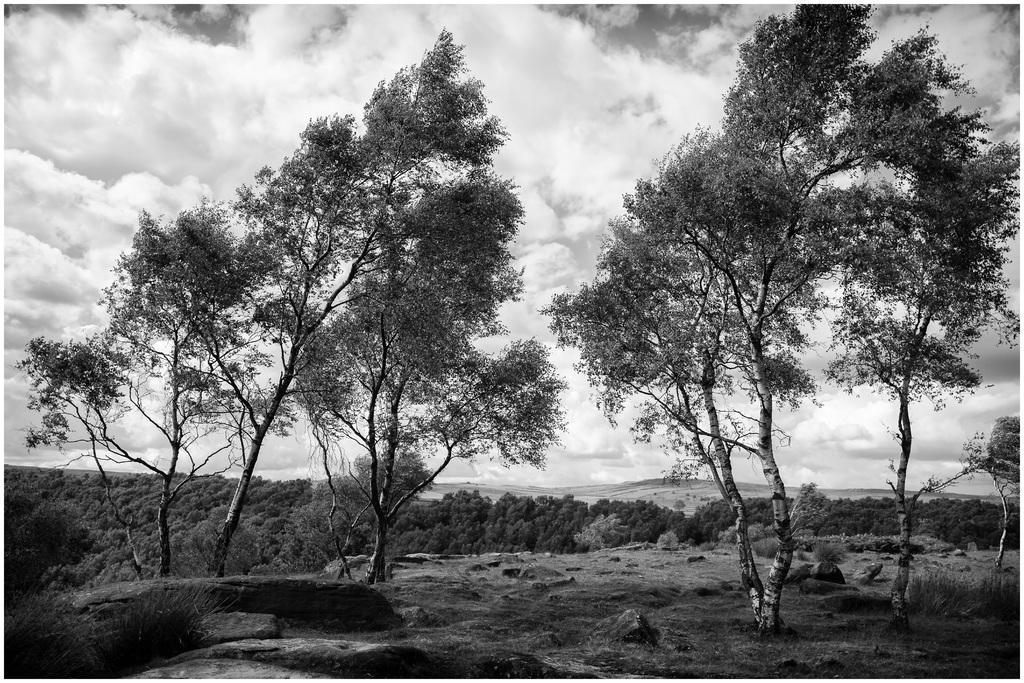Describe this image in one or two sentences. Sky is cloudy. Here we can see trees. 